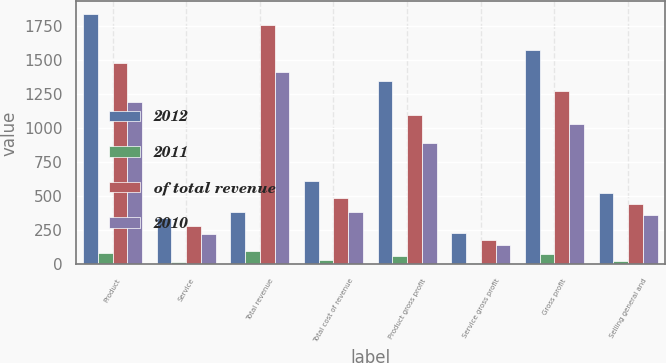Convert chart. <chart><loc_0><loc_0><loc_500><loc_500><stacked_bar_chart><ecel><fcel>Product<fcel>Service<fcel>Total revenue<fcel>Total cost of revenue<fcel>Product gross profit<fcel>Service gross profit<fcel>Gross profit<fcel>Selling general and<nl><fcel>2012<fcel>1836.2<fcel>342.6<fcel>383<fcel>608.5<fcel>1340.9<fcel>229.4<fcel>1570.3<fcel>522.2<nl><fcel>2011<fcel>84<fcel>16<fcel>100<fcel>28<fcel>62<fcel>11<fcel>72<fcel>24<nl><fcel>of total revenue<fcel>1478.9<fcel>278.4<fcel>1757.3<fcel>483.5<fcel>1096.6<fcel>177.2<fcel>1273.8<fcel>438.8<nl><fcel>2010<fcel>1189.1<fcel>223.9<fcel>1413<fcel>383<fcel>891.8<fcel>138.2<fcel>1030<fcel>358.8<nl></chart> 